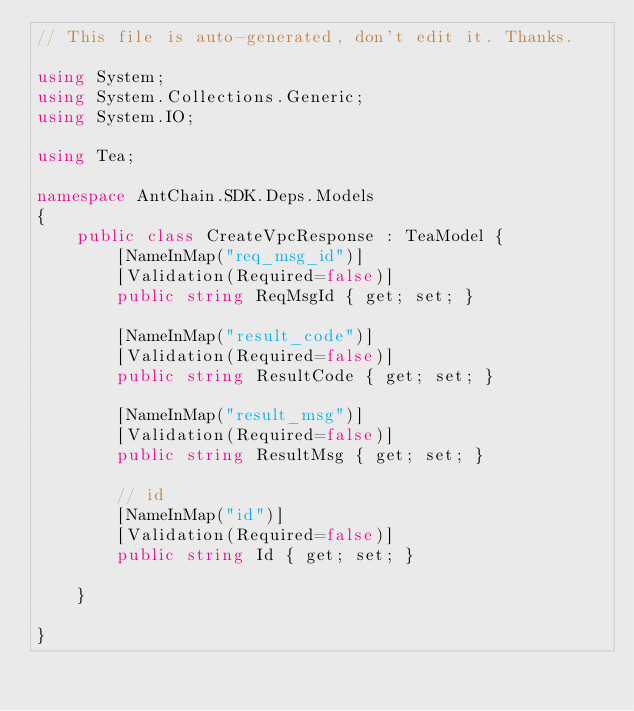Convert code to text. <code><loc_0><loc_0><loc_500><loc_500><_C#_>// This file is auto-generated, don't edit it. Thanks.

using System;
using System.Collections.Generic;
using System.IO;

using Tea;

namespace AntChain.SDK.Deps.Models
{
    public class CreateVpcResponse : TeaModel {
        [NameInMap("req_msg_id")]
        [Validation(Required=false)]
        public string ReqMsgId { get; set; }

        [NameInMap("result_code")]
        [Validation(Required=false)]
        public string ResultCode { get; set; }

        [NameInMap("result_msg")]
        [Validation(Required=false)]
        public string ResultMsg { get; set; }

        // id
        [NameInMap("id")]
        [Validation(Required=false)]
        public string Id { get; set; }

    }

}
</code> 